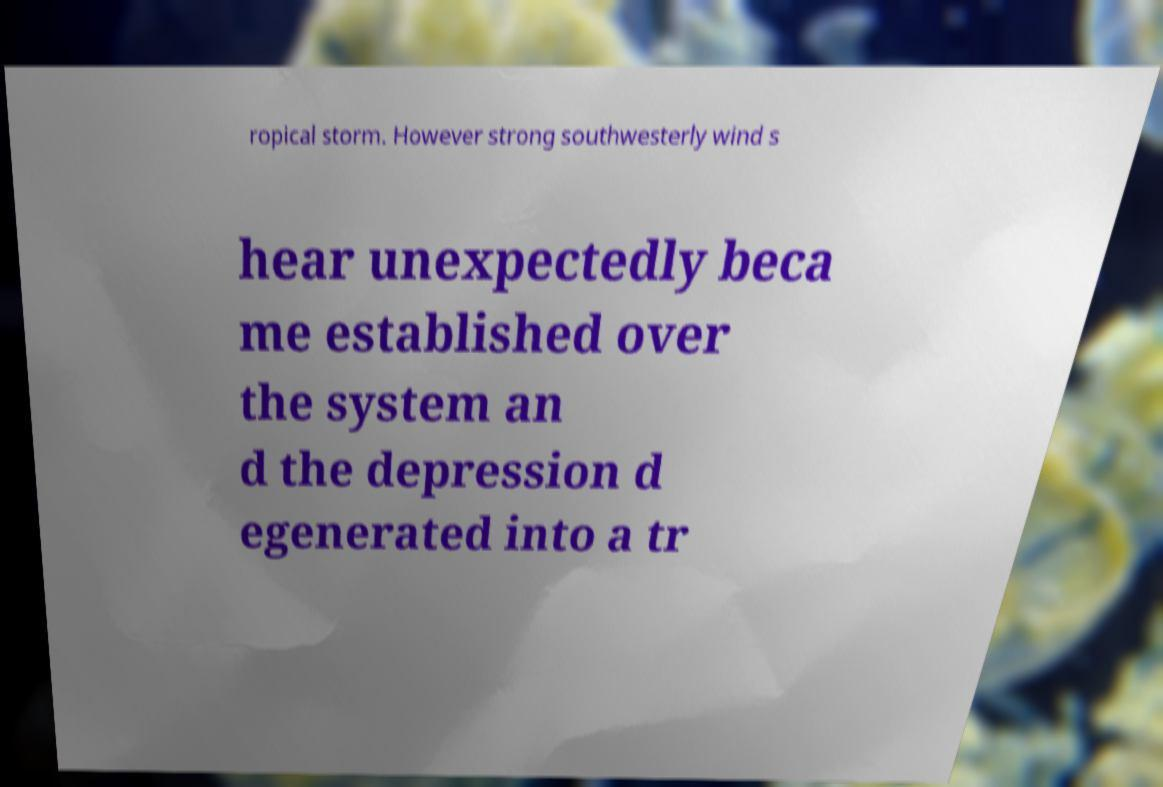Could you assist in decoding the text presented in this image and type it out clearly? ropical storm. However strong southwesterly wind s hear unexpectedly beca me established over the system an d the depression d egenerated into a tr 